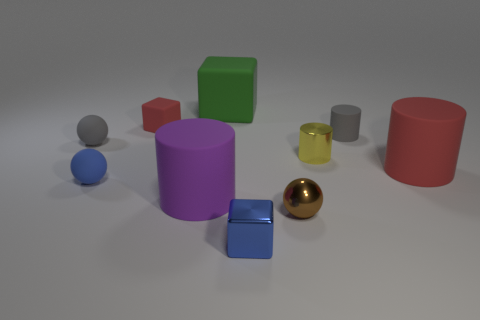Subtract all red rubber blocks. How many blocks are left? 2 Subtract all blue cubes. How many cubes are left? 2 Subtract 1 cubes. How many cubes are left? 2 Subtract all cyan cylinders. Subtract all cyan spheres. How many cylinders are left? 4 Subtract all cylinders. How many objects are left? 6 Add 5 tiny spheres. How many tiny spheres exist? 8 Subtract 1 brown balls. How many objects are left? 9 Subtract all yellow rubber things. Subtract all brown metal things. How many objects are left? 9 Add 8 tiny metal balls. How many tiny metal balls are left? 9 